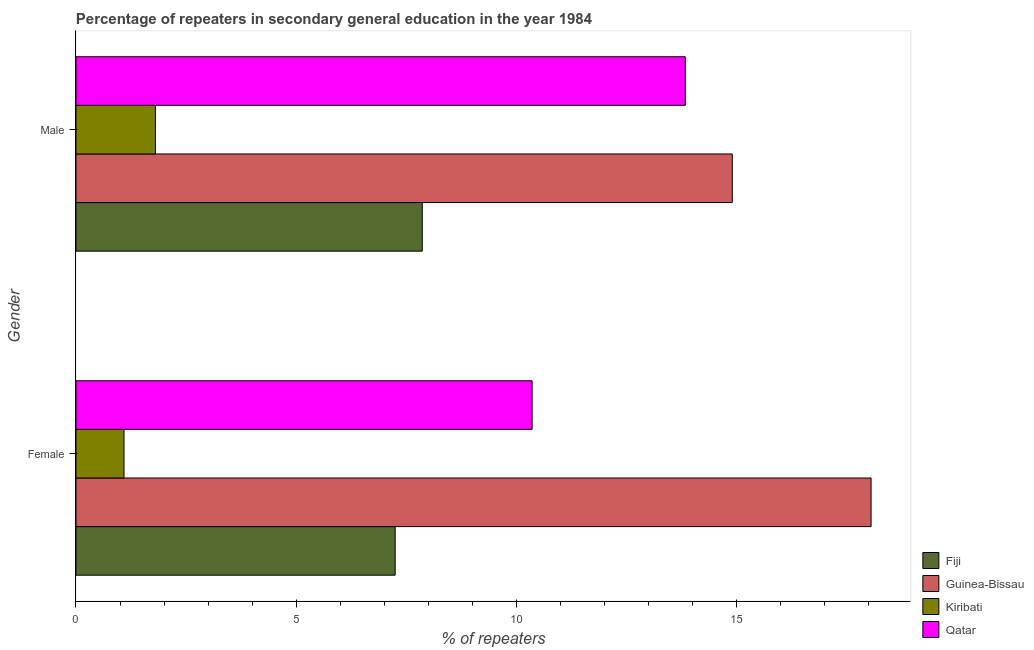Are the number of bars on each tick of the Y-axis equal?
Give a very brief answer. Yes. How many bars are there on the 2nd tick from the top?
Your response must be concise. 4. How many bars are there on the 1st tick from the bottom?
Your answer should be compact. 4. What is the percentage of female repeaters in Kiribati?
Your answer should be very brief. 1.09. Across all countries, what is the maximum percentage of male repeaters?
Make the answer very short. 14.91. Across all countries, what is the minimum percentage of female repeaters?
Give a very brief answer. 1.09. In which country was the percentage of male repeaters maximum?
Make the answer very short. Guinea-Bissau. In which country was the percentage of male repeaters minimum?
Provide a short and direct response. Kiribati. What is the total percentage of female repeaters in the graph?
Your answer should be very brief. 36.77. What is the difference between the percentage of female repeaters in Qatar and that in Fiji?
Keep it short and to the point. 3.11. What is the difference between the percentage of male repeaters in Fiji and the percentage of female repeaters in Qatar?
Make the answer very short. -2.5. What is the average percentage of male repeaters per country?
Make the answer very short. 9.61. What is the difference between the percentage of male repeaters and percentage of female repeaters in Kiribati?
Give a very brief answer. 0.71. In how many countries, is the percentage of female repeaters greater than 10 %?
Make the answer very short. 2. What is the ratio of the percentage of male repeaters in Qatar to that in Fiji?
Your response must be concise. 1.76. Is the percentage of female repeaters in Kiribati less than that in Guinea-Bissau?
Your answer should be compact. Yes. In how many countries, is the percentage of male repeaters greater than the average percentage of male repeaters taken over all countries?
Provide a succinct answer. 2. What does the 4th bar from the top in Female represents?
Ensure brevity in your answer.  Fiji. What does the 1st bar from the bottom in Male represents?
Your answer should be compact. Fiji. Are all the bars in the graph horizontal?
Make the answer very short. Yes. Are the values on the major ticks of X-axis written in scientific E-notation?
Your answer should be very brief. No. Does the graph contain any zero values?
Provide a succinct answer. No. Where does the legend appear in the graph?
Your answer should be compact. Bottom right. How many legend labels are there?
Your response must be concise. 4. How are the legend labels stacked?
Your answer should be compact. Vertical. What is the title of the graph?
Make the answer very short. Percentage of repeaters in secondary general education in the year 1984. Does "Cayman Islands" appear as one of the legend labels in the graph?
Your answer should be very brief. No. What is the label or title of the X-axis?
Your answer should be compact. % of repeaters. What is the % of repeaters in Fiji in Female?
Give a very brief answer. 7.25. What is the % of repeaters in Guinea-Bissau in Female?
Offer a terse response. 18.06. What is the % of repeaters in Kiribati in Female?
Make the answer very short. 1.09. What is the % of repeaters in Qatar in Female?
Give a very brief answer. 10.36. What is the % of repeaters of Fiji in Male?
Make the answer very short. 7.87. What is the % of repeaters in Guinea-Bissau in Male?
Provide a short and direct response. 14.91. What is the % of repeaters of Kiribati in Male?
Make the answer very short. 1.81. What is the % of repeaters in Qatar in Male?
Provide a succinct answer. 13.84. Across all Gender, what is the maximum % of repeaters in Fiji?
Offer a very short reply. 7.87. Across all Gender, what is the maximum % of repeaters in Guinea-Bissau?
Your answer should be very brief. 18.06. Across all Gender, what is the maximum % of repeaters in Kiribati?
Offer a very short reply. 1.81. Across all Gender, what is the maximum % of repeaters in Qatar?
Your response must be concise. 13.84. Across all Gender, what is the minimum % of repeaters in Fiji?
Provide a short and direct response. 7.25. Across all Gender, what is the minimum % of repeaters in Guinea-Bissau?
Your answer should be very brief. 14.91. Across all Gender, what is the minimum % of repeaters of Kiribati?
Your answer should be compact. 1.09. Across all Gender, what is the minimum % of repeaters of Qatar?
Offer a very short reply. 10.36. What is the total % of repeaters of Fiji in the graph?
Offer a terse response. 15.12. What is the total % of repeaters of Guinea-Bissau in the graph?
Ensure brevity in your answer.  32.97. What is the total % of repeaters in Kiribati in the graph?
Provide a succinct answer. 2.9. What is the total % of repeaters of Qatar in the graph?
Make the answer very short. 24.2. What is the difference between the % of repeaters in Fiji in Female and that in Male?
Keep it short and to the point. -0.62. What is the difference between the % of repeaters in Guinea-Bissau in Female and that in Male?
Your answer should be very brief. 3.15. What is the difference between the % of repeaters in Kiribati in Female and that in Male?
Keep it short and to the point. -0.71. What is the difference between the % of repeaters of Qatar in Female and that in Male?
Provide a short and direct response. -3.48. What is the difference between the % of repeaters in Fiji in Female and the % of repeaters in Guinea-Bissau in Male?
Offer a terse response. -7.66. What is the difference between the % of repeaters in Fiji in Female and the % of repeaters in Kiribati in Male?
Your answer should be very brief. 5.45. What is the difference between the % of repeaters of Fiji in Female and the % of repeaters of Qatar in Male?
Make the answer very short. -6.59. What is the difference between the % of repeaters of Guinea-Bissau in Female and the % of repeaters of Kiribati in Male?
Make the answer very short. 16.26. What is the difference between the % of repeaters of Guinea-Bissau in Female and the % of repeaters of Qatar in Male?
Your answer should be compact. 4.22. What is the difference between the % of repeaters in Kiribati in Female and the % of repeaters in Qatar in Male?
Keep it short and to the point. -12.75. What is the average % of repeaters of Fiji per Gender?
Keep it short and to the point. 7.56. What is the average % of repeaters of Guinea-Bissau per Gender?
Make the answer very short. 16.49. What is the average % of repeaters in Kiribati per Gender?
Your answer should be compact. 1.45. What is the average % of repeaters of Qatar per Gender?
Give a very brief answer. 12.1. What is the difference between the % of repeaters of Fiji and % of repeaters of Guinea-Bissau in Female?
Your answer should be compact. -10.81. What is the difference between the % of repeaters of Fiji and % of repeaters of Kiribati in Female?
Give a very brief answer. 6.16. What is the difference between the % of repeaters in Fiji and % of repeaters in Qatar in Female?
Make the answer very short. -3.11. What is the difference between the % of repeaters in Guinea-Bissau and % of repeaters in Kiribati in Female?
Offer a very short reply. 16.97. What is the difference between the % of repeaters in Guinea-Bissau and % of repeaters in Qatar in Female?
Your answer should be compact. 7.7. What is the difference between the % of repeaters in Kiribati and % of repeaters in Qatar in Female?
Offer a very short reply. -9.27. What is the difference between the % of repeaters in Fiji and % of repeaters in Guinea-Bissau in Male?
Your answer should be very brief. -7.04. What is the difference between the % of repeaters of Fiji and % of repeaters of Kiribati in Male?
Offer a very short reply. 6.06. What is the difference between the % of repeaters in Fiji and % of repeaters in Qatar in Male?
Your answer should be very brief. -5.98. What is the difference between the % of repeaters of Guinea-Bissau and % of repeaters of Kiribati in Male?
Give a very brief answer. 13.1. What is the difference between the % of repeaters of Guinea-Bissau and % of repeaters of Qatar in Male?
Provide a short and direct response. 1.07. What is the difference between the % of repeaters of Kiribati and % of repeaters of Qatar in Male?
Ensure brevity in your answer.  -12.04. What is the ratio of the % of repeaters of Fiji in Female to that in Male?
Your answer should be compact. 0.92. What is the ratio of the % of repeaters of Guinea-Bissau in Female to that in Male?
Provide a short and direct response. 1.21. What is the ratio of the % of repeaters in Kiribati in Female to that in Male?
Offer a very short reply. 0.6. What is the ratio of the % of repeaters of Qatar in Female to that in Male?
Provide a short and direct response. 0.75. What is the difference between the highest and the second highest % of repeaters in Fiji?
Offer a very short reply. 0.62. What is the difference between the highest and the second highest % of repeaters of Guinea-Bissau?
Make the answer very short. 3.15. What is the difference between the highest and the second highest % of repeaters in Kiribati?
Offer a very short reply. 0.71. What is the difference between the highest and the second highest % of repeaters of Qatar?
Make the answer very short. 3.48. What is the difference between the highest and the lowest % of repeaters of Fiji?
Offer a terse response. 0.62. What is the difference between the highest and the lowest % of repeaters of Guinea-Bissau?
Offer a terse response. 3.15. What is the difference between the highest and the lowest % of repeaters in Kiribati?
Provide a short and direct response. 0.71. What is the difference between the highest and the lowest % of repeaters of Qatar?
Keep it short and to the point. 3.48. 